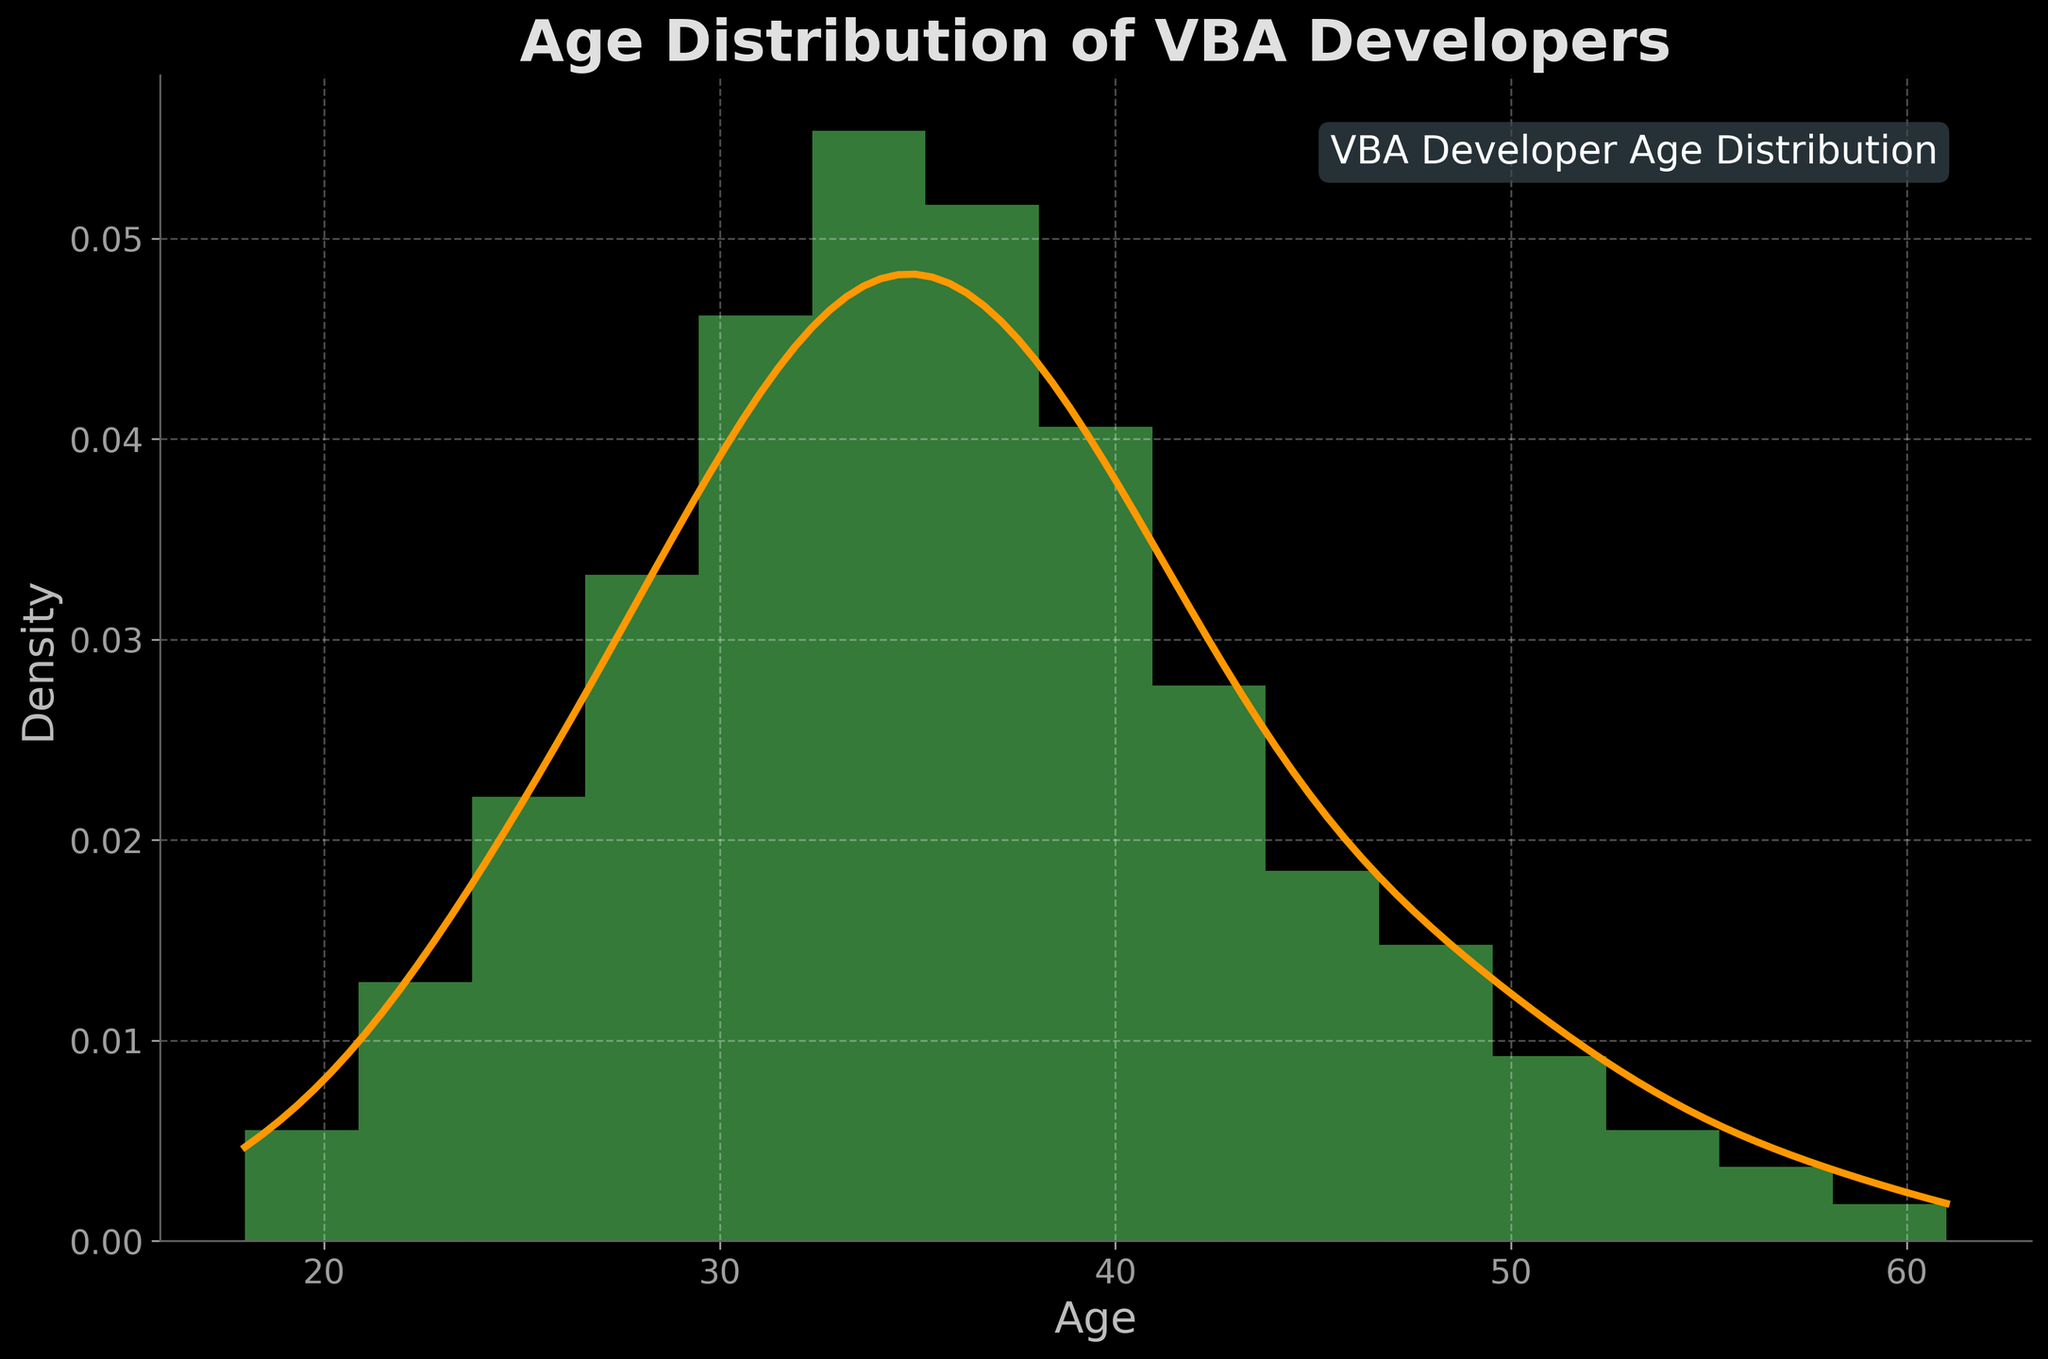What's the title of the plot? The title is typically found at the top of the plot and should be clearly labeled. In this case, "Age Distribution of VBA Developers" is prominently displayed.
Answer: Age Distribution of VBA Developers What does the y-axis represent? The label on the y-axis should indicate what the axis measures. In this plot, the y-axis represents 'Density'.
Answer: Density What color is the KDE (density) curve? The KDE curve is distinct due to its unique color compared to the histogram bars. Here, the KDE curve is plotted in an orange color.
Answer: Orange How many age groups are there in the histogram? Count the number of bars in the histogram; each bar represents a different age group. In the plot, you can count 15 distinct bars.
Answer: 15 Which age group has the highest frequency? Observe the histogram bars to see which one reaches the highest point. In this plot, the age group at 34 has the highest bar.
Answer: Age 34 Around what age does the KDE peak? Follow the KDE curve to the highest point and then check the corresponding age on the x-axis. The KDE curve peaks around age 34.
Answer: Around age 34 What's the density value at the peak of the KDE curve? Locate the highest point on the KDE curve and read the corresponding y-axis value. The peak density value is approximately 0.1.
Answer: Approximately 0.1 Compare the density at age 25 versus age 55. Which is higher? Look at the KDE curve values at ages 25 and 55 and compare their heights. The density at age 25 is higher than at age 55.
Answer: Age 25 What is the range of ages shown in the plot? Identify the minimum and maximum age values along the x-axis. The plot ranges from age 18 to age 61.
Answer: 18 to 61 What significant age range shows a higher density of VBA developers? Observe the range where the KDE curve maintains higher values. The significant range with higher density is roughly between ages 28 and 40.
Answer: Ages 28 to 40 